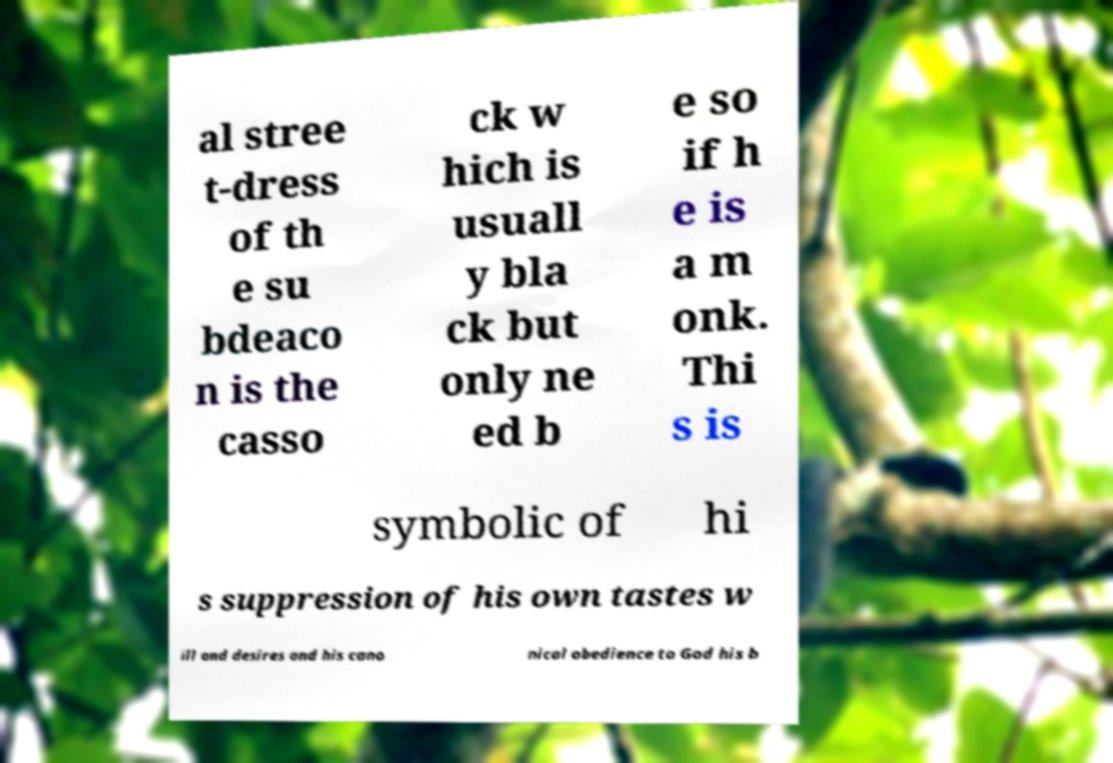Can you accurately transcribe the text from the provided image for me? al stree t-dress of th e su bdeaco n is the casso ck w hich is usuall y bla ck but only ne ed b e so if h e is a m onk. Thi s is symbolic of hi s suppression of his own tastes w ill and desires and his cano nical obedience to God his b 